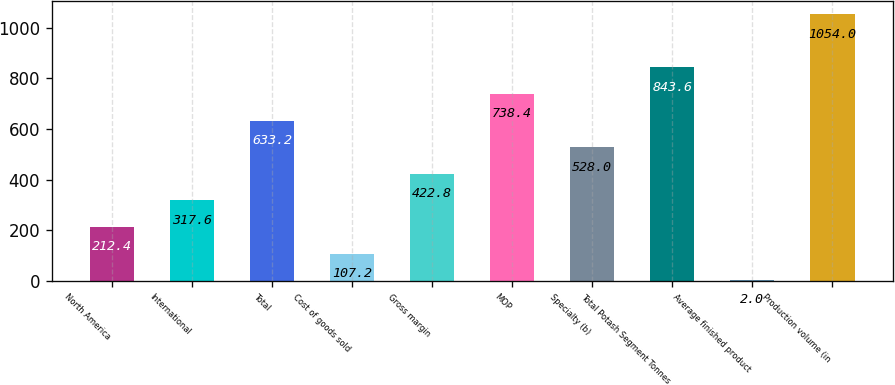<chart> <loc_0><loc_0><loc_500><loc_500><bar_chart><fcel>North America<fcel>International<fcel>Total<fcel>Cost of goods sold<fcel>Gross margin<fcel>MOP<fcel>Specialty (b)<fcel>Total Potash Segment Tonnes<fcel>Average finished product<fcel>Production volume (in<nl><fcel>212.4<fcel>317.6<fcel>633.2<fcel>107.2<fcel>422.8<fcel>738.4<fcel>528<fcel>843.6<fcel>2<fcel>1054<nl></chart> 